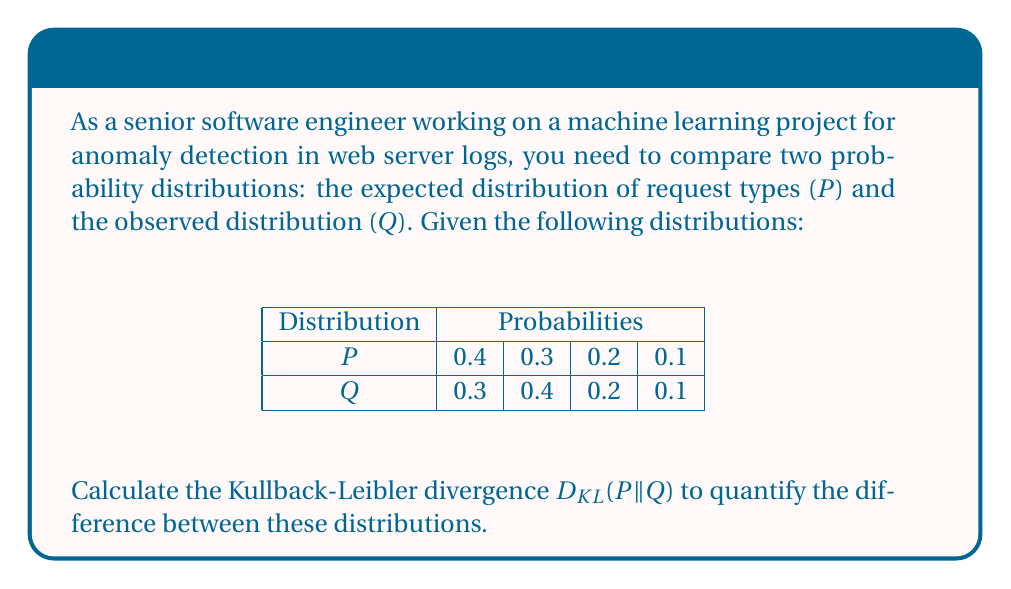Provide a solution to this math problem. To calculate the Kullback-Leibler divergence between probability distributions P and Q, we use the formula:

$$D_{KL}(P||Q) = \sum_{i} P(i) \log\left(\frac{P(i)}{Q(i)}\right)$$

Let's calculate this step-by-step:

1) For i = 0:
   $P(0) = 0.4$, $Q(0) = 0.3$
   $0.4 \log(\frac{0.4}{0.3}) = 0.4 \log(1.3333) \approx 0.0461$

2) For i = 1:
   $P(1) = 0.3$, $Q(1) = 0.4$
   $0.3 \log(\frac{0.3}{0.4}) = 0.3 \log(0.75) \approx -0.0863$

3) For i = 2:
   $P(2) = 0.2$, $Q(2) = 0.2$
   $0.2 \log(\frac{0.2}{0.2}) = 0.2 \log(1) = 0$

4) For i = 3:
   $P(3) = 0.1$, $Q(3) = 0.1$
   $0.1 \log(\frac{0.1}{0.1}) = 0.1 \log(1) = 0$

5) Sum all these values:
   $D_{KL}(P||Q) = 0.0461 + (-0.0863) + 0 + 0 = -0.0402$

The negative result indicates that Q is "closer" to P than a uniform distribution would be.
Answer: $-0.0402$ 